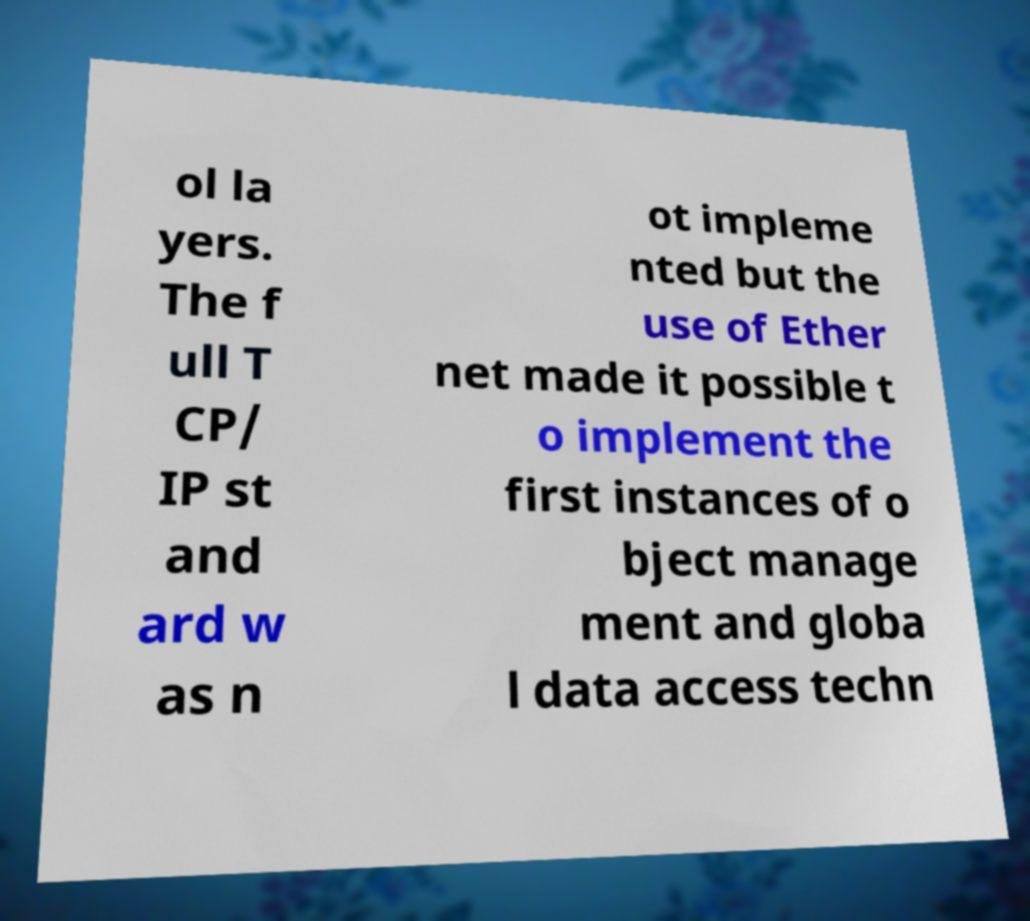I need the written content from this picture converted into text. Can you do that? ol la yers. The f ull T CP/ IP st and ard w as n ot impleme nted but the use of Ether net made it possible t o implement the first instances of o bject manage ment and globa l data access techn 